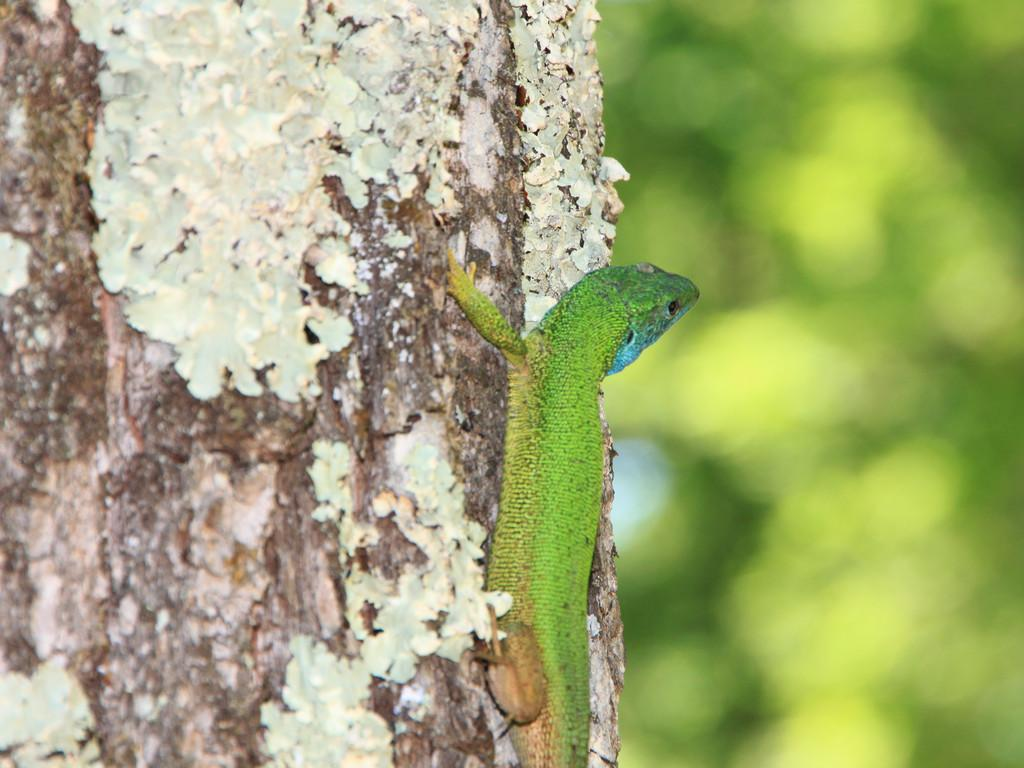What type of animal is in the image? There is a reptile in the image. What color is the reptile? The reptile is green in color. Where is the reptile located in the image? The reptile is on a trunk. What is the color of the background in the image? The background of the image is green. Can you see any fairies flying around the reptile in the image? There are no fairies present in the image; it only features a green reptile on a trunk with a green background. 